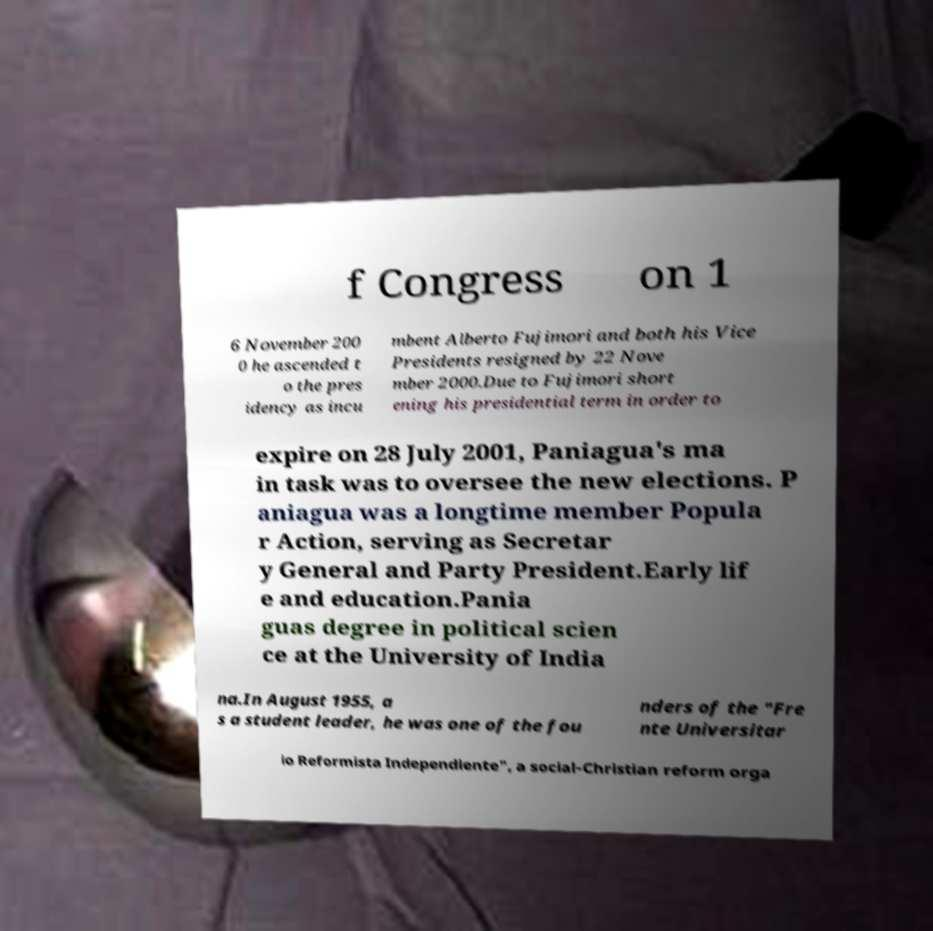Can you read and provide the text displayed in the image?This photo seems to have some interesting text. Can you extract and type it out for me? f Congress on 1 6 November 200 0 he ascended t o the pres idency as incu mbent Alberto Fujimori and both his Vice Presidents resigned by 22 Nove mber 2000.Due to Fujimori short ening his presidential term in order to expire on 28 July 2001, Paniagua's ma in task was to oversee the new elections. P aniagua was a longtime member Popula r Action, serving as Secretar y General and Party President.Early lif e and education.Pania guas degree in political scien ce at the University of India na.In August 1955, a s a student leader, he was one of the fou nders of the "Fre nte Universitar io Reformista Independiente", a social-Christian reform orga 